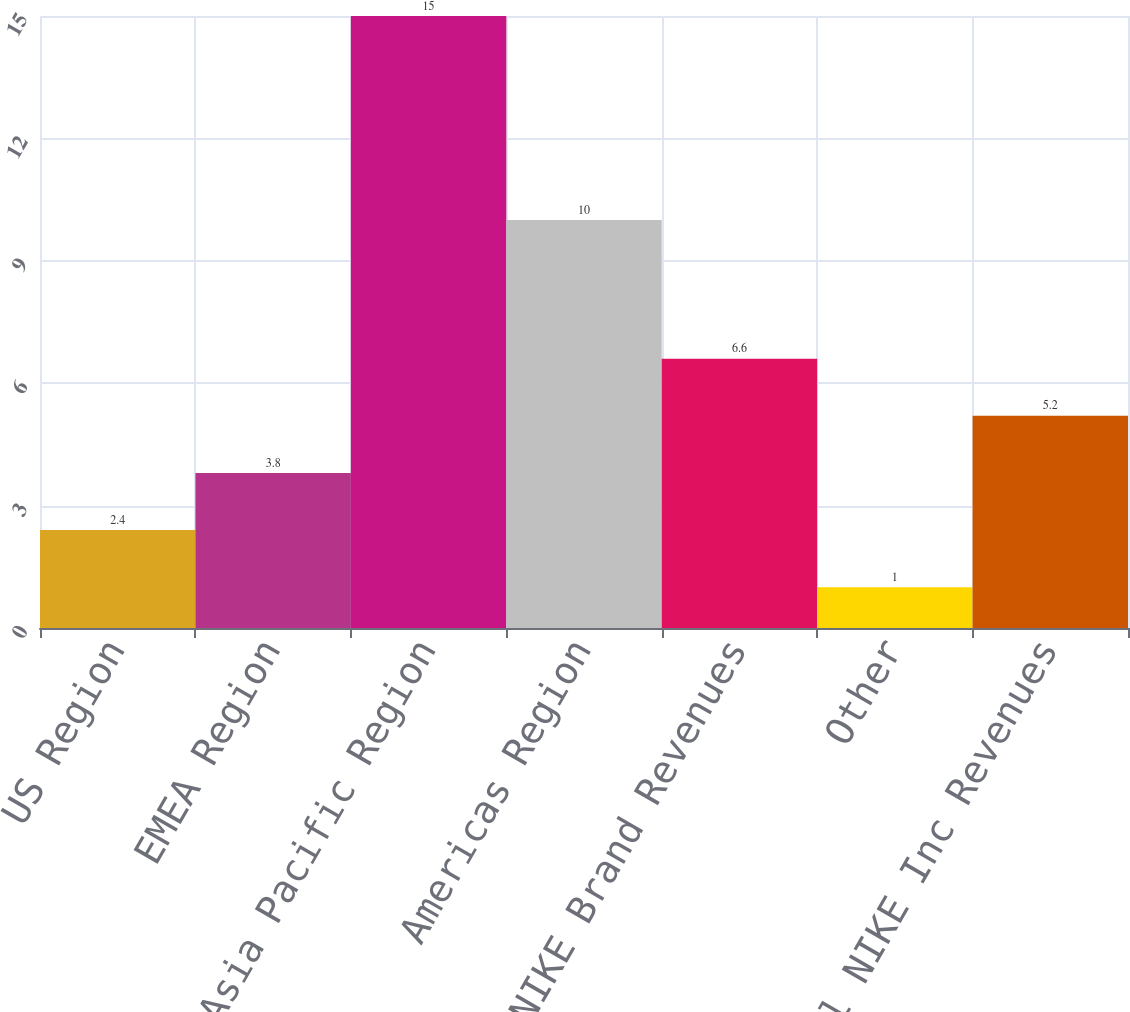Convert chart to OTSL. <chart><loc_0><loc_0><loc_500><loc_500><bar_chart><fcel>US Region<fcel>EMEA Region<fcel>Asia Pacific Region<fcel>Americas Region<fcel>Total NIKE Brand Revenues<fcel>Other<fcel>Total NIKE Inc Revenues<nl><fcel>2.4<fcel>3.8<fcel>15<fcel>10<fcel>6.6<fcel>1<fcel>5.2<nl></chart> 